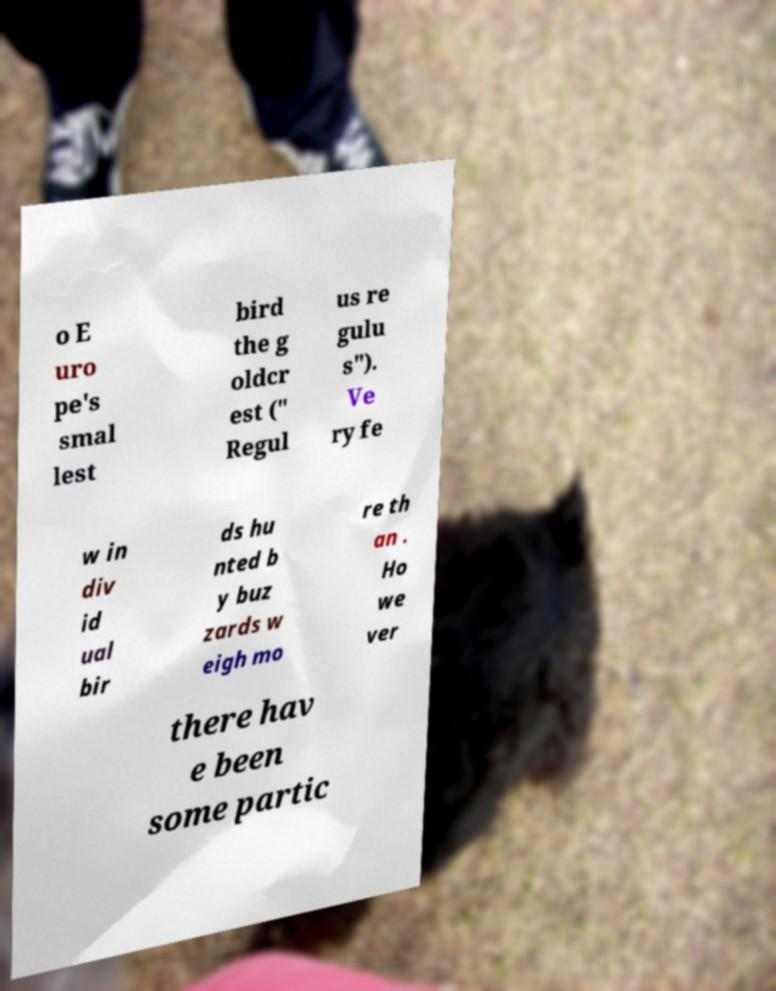Could you extract and type out the text from this image? o E uro pe's smal lest bird the g oldcr est (" Regul us re gulu s"). Ve ry fe w in div id ual bir ds hu nted b y buz zards w eigh mo re th an . Ho we ver there hav e been some partic 